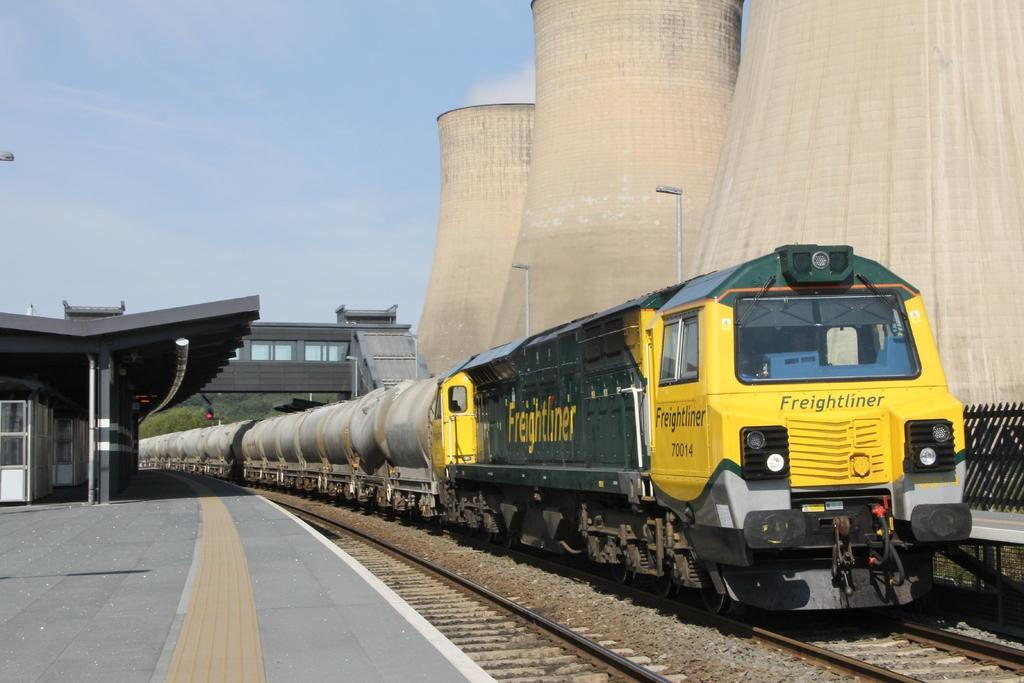What is the main subject of the image? The main subject of the image is a train on a track. What else can be seen in the image besides the train? There is a platform, a shed, and a bridge visible in the background of the image. Trees and the sky are also present in the background. What type of jam is being served on the platform in the image? There is no jam present in the image; it features a train on a track, a platform, a shed, a bridge, trees, and the sky. 